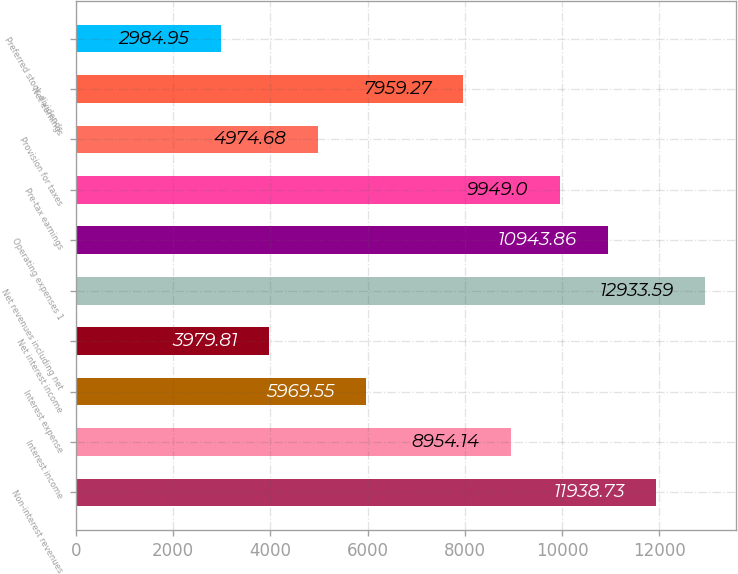Convert chart. <chart><loc_0><loc_0><loc_500><loc_500><bar_chart><fcel>Non-interest revenues<fcel>Interest income<fcel>Interest expense<fcel>Net interest income<fcel>Net revenues including net<fcel>Operating expenses 1<fcel>Pre-tax earnings<fcel>Provision for taxes<fcel>Net earnings<fcel>Preferred stock dividends<nl><fcel>11938.7<fcel>8954.14<fcel>5969.55<fcel>3979.81<fcel>12933.6<fcel>10943.9<fcel>9949<fcel>4974.68<fcel>7959.27<fcel>2984.95<nl></chart> 